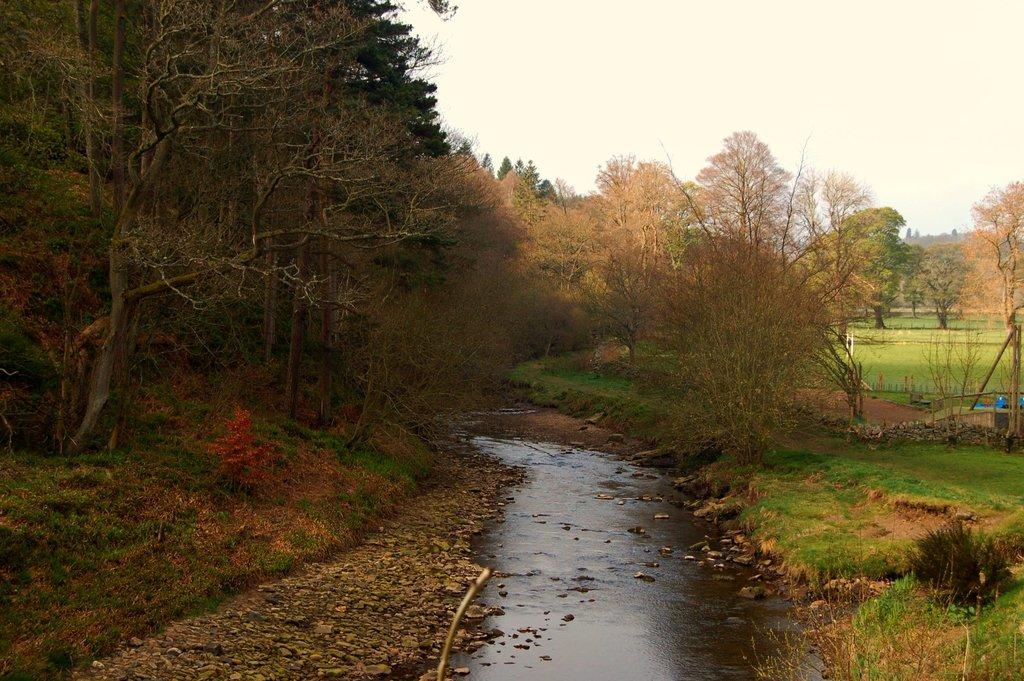What type of natural environment is depicted in the image? The image features water, grass, trees, and the sky, which suggests a natural outdoor setting. Can you describe the water in the image? The water is visible in the image, but its specific characteristics are not mentioned in the provided facts. What type of vegetation is present in the image? There are trees and grass in the image. What is visible in the background of the image? The sky is visible in the image. What is the answer to the riddle hidden in the image? There is no riddle present in the image, so it is not possible to answer that question. 